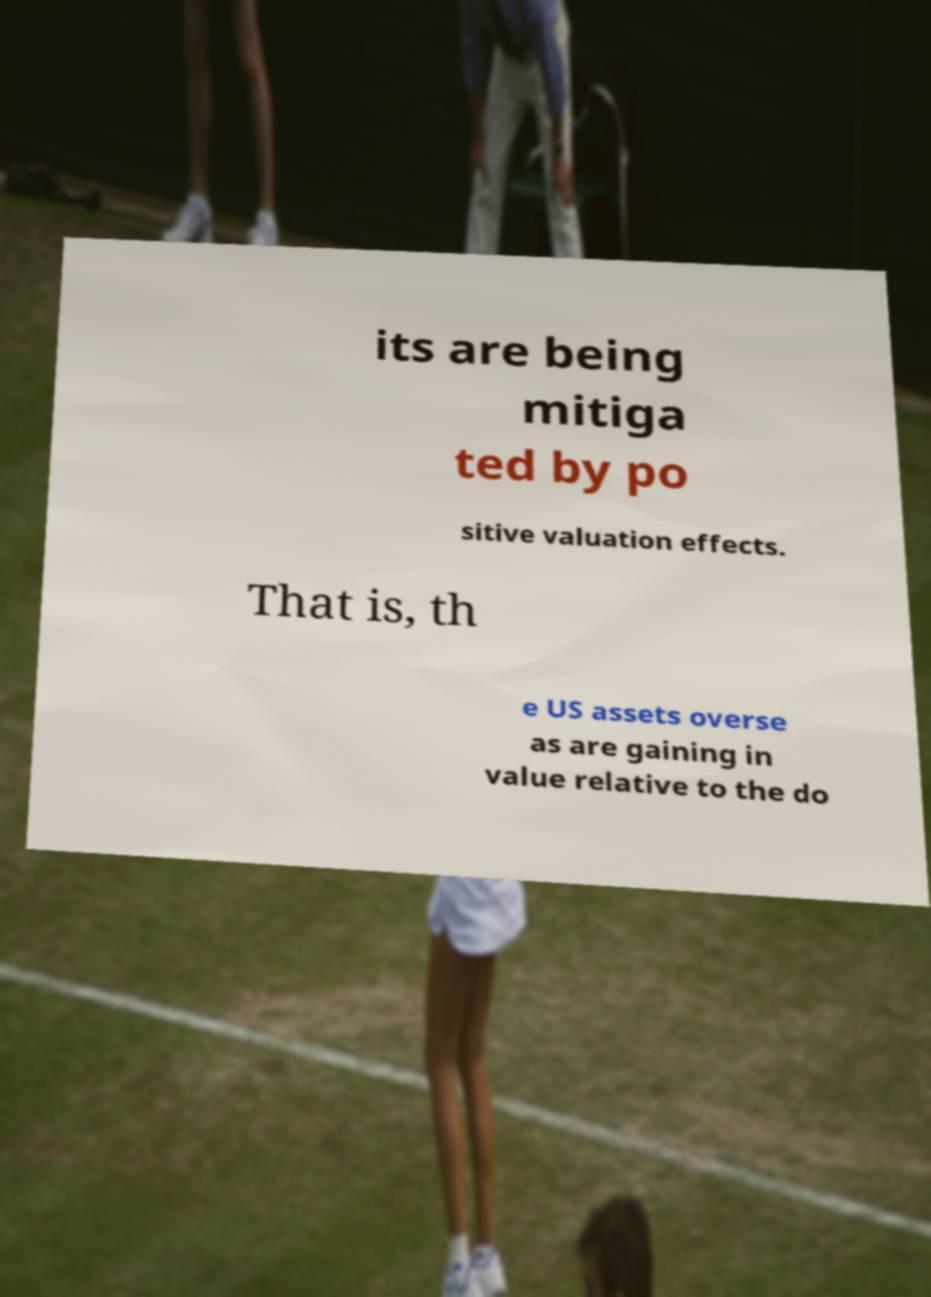Can you read and provide the text displayed in the image?This photo seems to have some interesting text. Can you extract and type it out for me? its are being mitiga ted by po sitive valuation effects. That is, th e US assets overse as are gaining in value relative to the do 